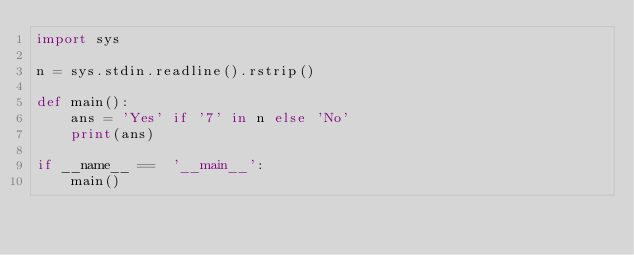Convert code to text. <code><loc_0><loc_0><loc_500><loc_500><_Python_>import sys

n = sys.stdin.readline().rstrip()

def main():
    ans = 'Yes' if '7' in n else 'No'
    print(ans)

if __name__ ==  '__main__':
    main()</code> 